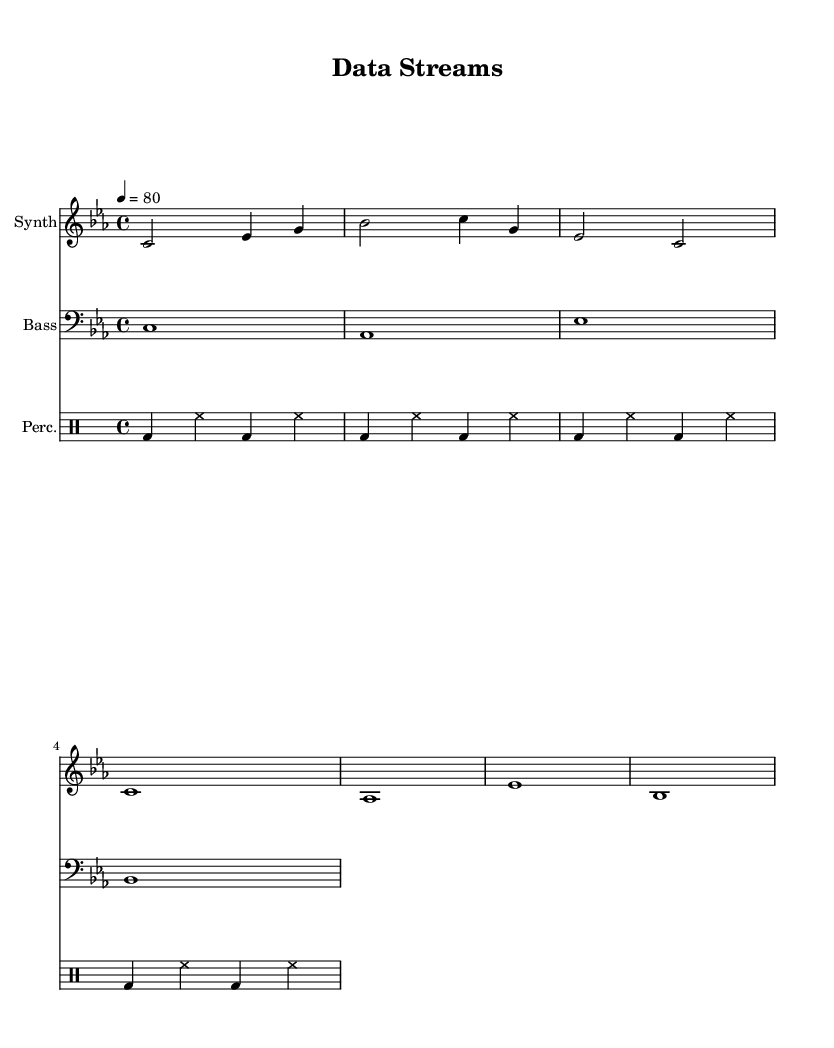What is the key signature of this music? The key signature is C minor, indicated by three flats in the key signature section of the score.
Answer: C minor What is the time signature of this piece? The time signature is 4/4, as marked at the beginning of the score, indicating that there are four beats in each measure.
Answer: 4/4 What is the tempo marking for the music? The tempo marking indicates a tempo of 80 beats per minute, which is noted at the start of the score with "4 = 80."
Answer: 80 What instruments are included in this score? The score includes three instruments: Synth, Bass, and Percussion, each indicated at the beginning of their respective staff or rhythmic section.
Answer: Synth, Bass, Percussion How many measures are in the Synth part? The Synth part has a total of 7 measures, counted by observing the bar lines within the staff.
Answer: 7 What is the rhythmic pattern used in the percussion part? The percussion utilizes a consistent pattern of bass drums and hi-hats, specifically a repeated sequence of: bass drum followed by hi-hats.
Answer: bass drum and hi-hats Which voice plays the longest note value? The Synth voice plays the longest note value, with several whole notes throughout the part, specifically in measures where the note is sustained.
Answer: Synth 